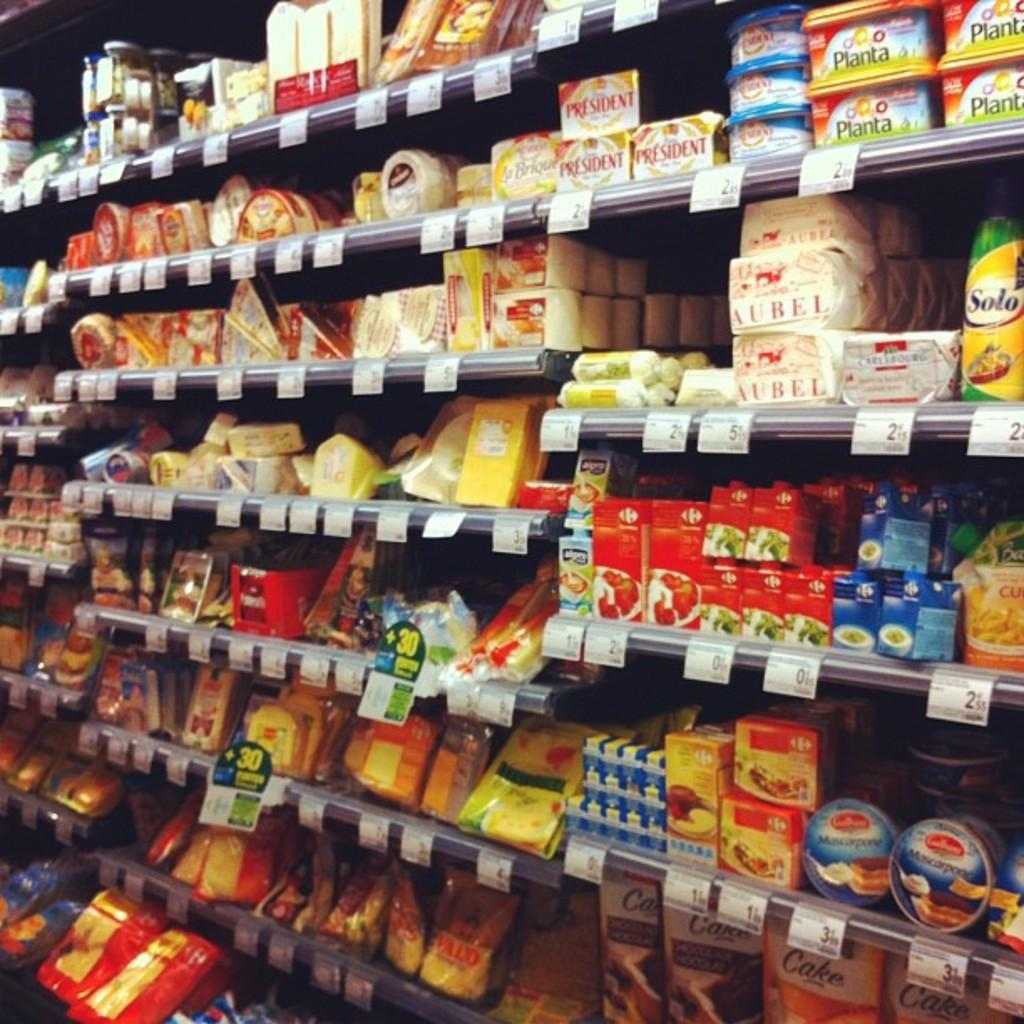<image>
Render a clear and concise summary of the photo. A grocery store aisle with various products on it including Planta. 